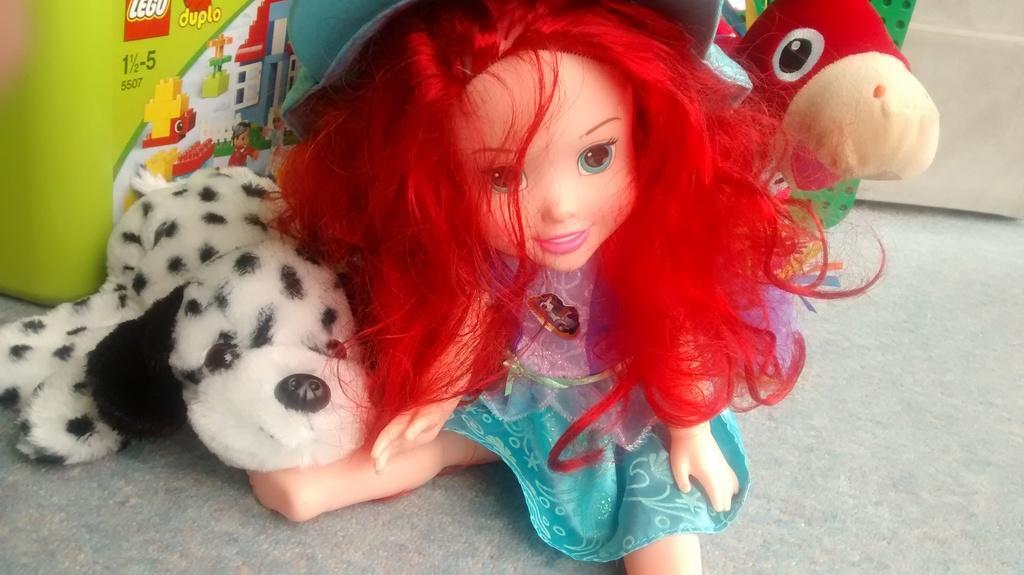In one or two sentences, can you explain what this image depicts? In this image we can see a baby girl toy on the floor. Here we can see a dog and a bird toys as well. 